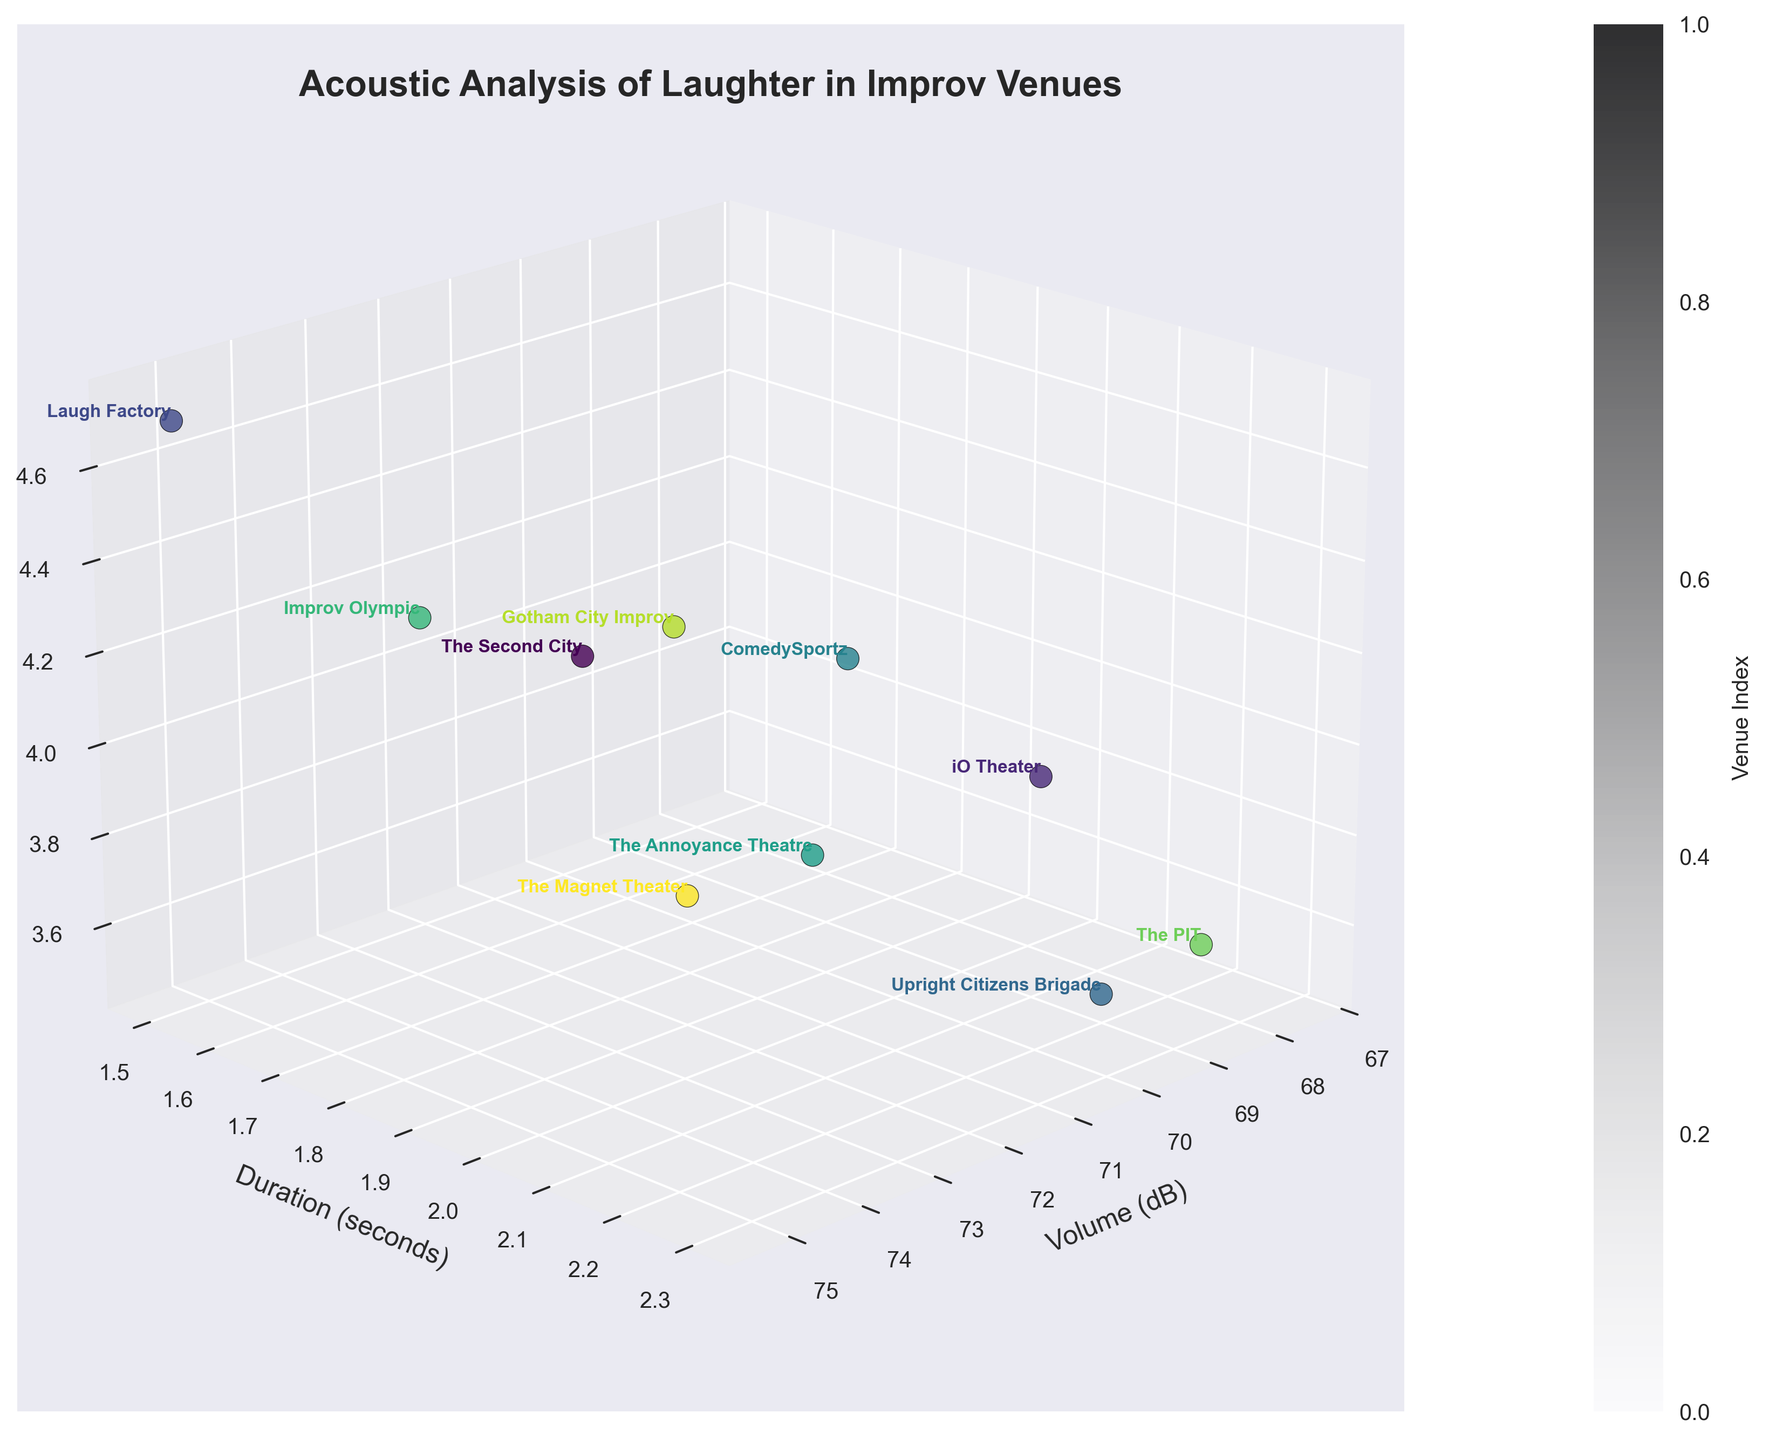What is the title of the plot? The title is displayed at the top of the plot.
Answer: Acoustic Analysis of Laughter in Improv Venues How many venues are represented in the plot? Count the number of different data points or text labels for venues in the plot.
Answer: 10 Which venue has the highest laughter frequency? Identify the highest z-axis value (Frequency) and look at the corresponding venue label.
Answer: Laugh Factory Which venue has the lowest volume in decibels? Identify the lowest x-axis value (Volume) and look at the corresponding venue label.
Answer: The PIT What's the average duration of laughter across all venues? Sum all the duration values and divide by the number of venues: (1.8 + 2.1 + 1.5 + 2.3 + 1.9 + 2.0 + 1.7 + 2.2 + 1.6 + 1.9) / 10
Answer: 1.9 seconds Which venues have a laughter frequency greater than 4 laughs/minute? Identify the points with z-axis values greater than 4 and note the corresponding venue labels.
Answer: The Second City, Laugh Factory, Improv Olympic, ComedySportz Compare the duration and frequency of laughter at The Second City and iO Theater. Extract and compare the values: The Second City (1.8 seconds, 4.2 laughs/minute), iO Theater (2.1 seconds, 3.9 laughs/minute).
Answer: The Second City: 1.8 seconds, 4.2 laughs/minute; iO Theater: 2.1 seconds, 3.9 laughs/minute Which venue has the highest volume and how long is the duration of laughter there? Identify the highest x-axis value (Volume) and check the corresponding y-axis value (Duration).
Answer: Laugh Factory, 1.5 seconds What pattern do you see in the relationship between volume and duration of laughter across venues? Analyze the positions of data points relative to x-axis (Volume) and y-axis (Duration). Typically, venues with higher volume have shorter laughter duration.
Answer: Higher volume often corresponds to shorter laughter duration How does Upright Citizens Brigade's laughter duration compare to ComedySportz? Extract and compare the y-axis values: Upright Citizens Brigade (2.3 seconds), ComedySportz (1.9 seconds).
Answer: Upright Citizens Brigade: 2.3 seconds, ComedySportz: 1.9 seconds 